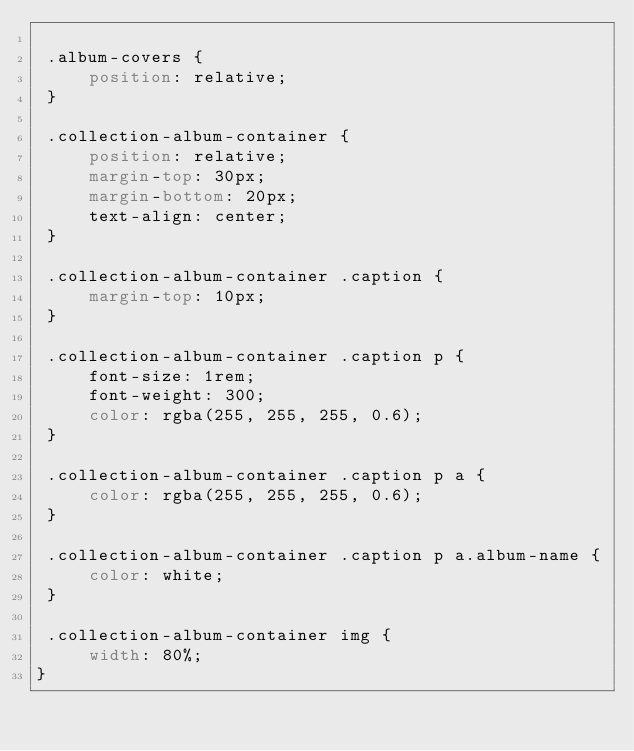Convert code to text. <code><loc_0><loc_0><loc_500><loc_500><_CSS_>
 .album-covers {
     position: relative;
 }
 
 .collection-album-container {
     position: relative;
     margin-top: 30px;
     margin-bottom: 20px;
     text-align: center;
 }
 
 .collection-album-container .caption {
     margin-top: 10px;
 }
 
 .collection-album-container .caption p {
     font-size: 1rem;
     font-weight: 300;
     color: rgba(255, 255, 255, 0.6);
 }
 
 .collection-album-container .caption p a {
     color: rgba(255, 255, 255, 0.6);
 }
 
 .collection-album-container .caption p a.album-name {
     color: white;
 }
 
 .collection-album-container img {
     width: 80%;
}</code> 